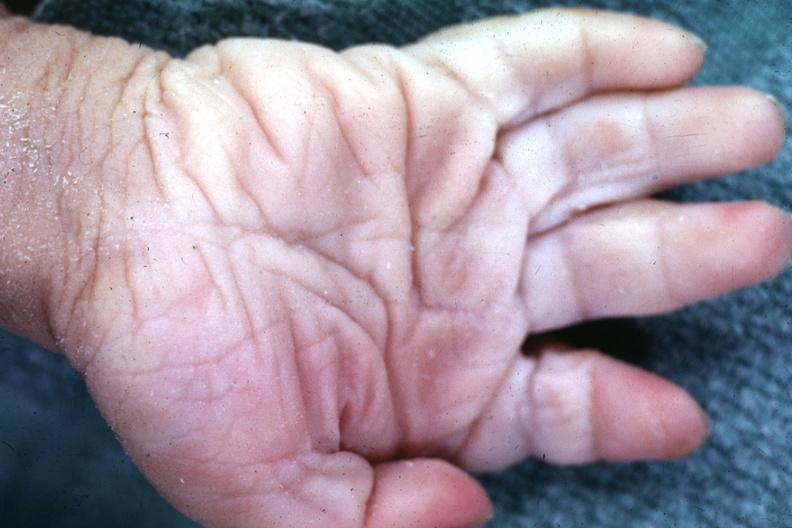does this image show simian crease?
Answer the question using a single word or phrase. Yes 